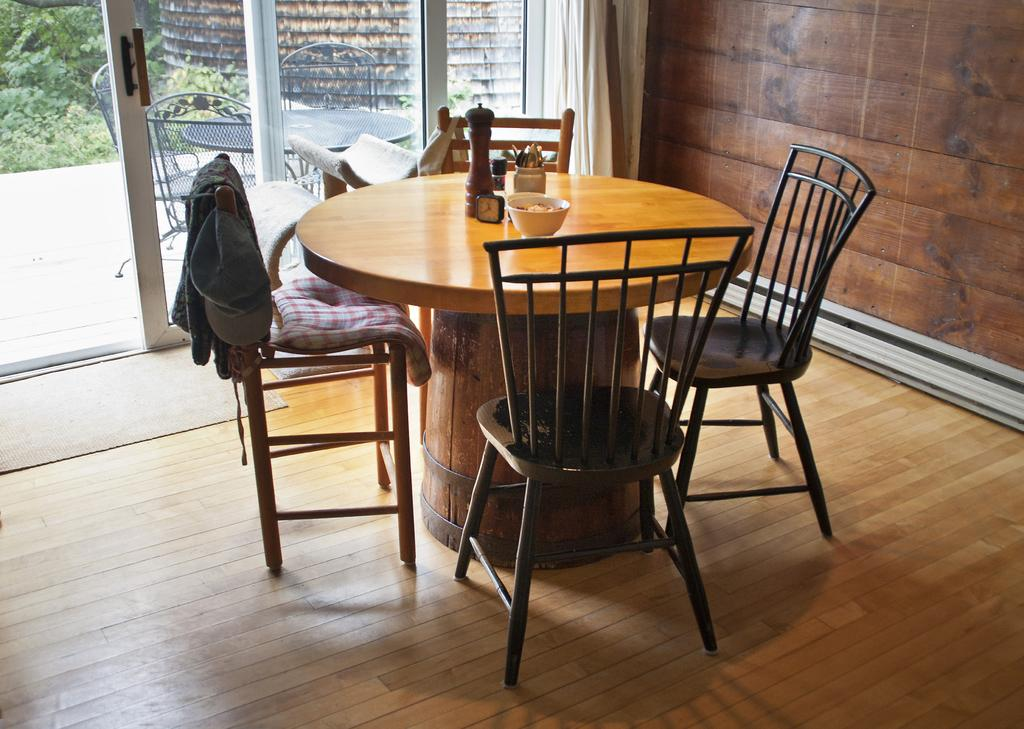What type of furniture can be seen in the image? There is a table and chairs arrangement in the image. What type of door is visible in the image? There is a glass door in the image. Where is the scarecrow standing in the image? There is no scarecrow present in the image. What type of business is being conducted in the image? The image does not depict any business activity; it only shows a table and chairs arrangement and a glass door. 